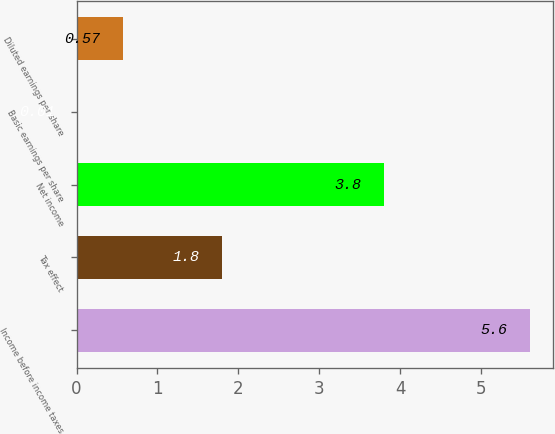<chart> <loc_0><loc_0><loc_500><loc_500><bar_chart><fcel>Income before income taxes<fcel>Tax effect<fcel>Net income<fcel>Basic earnings per share<fcel>Diluted earnings per share<nl><fcel>5.6<fcel>1.8<fcel>3.8<fcel>0.01<fcel>0.57<nl></chart> 